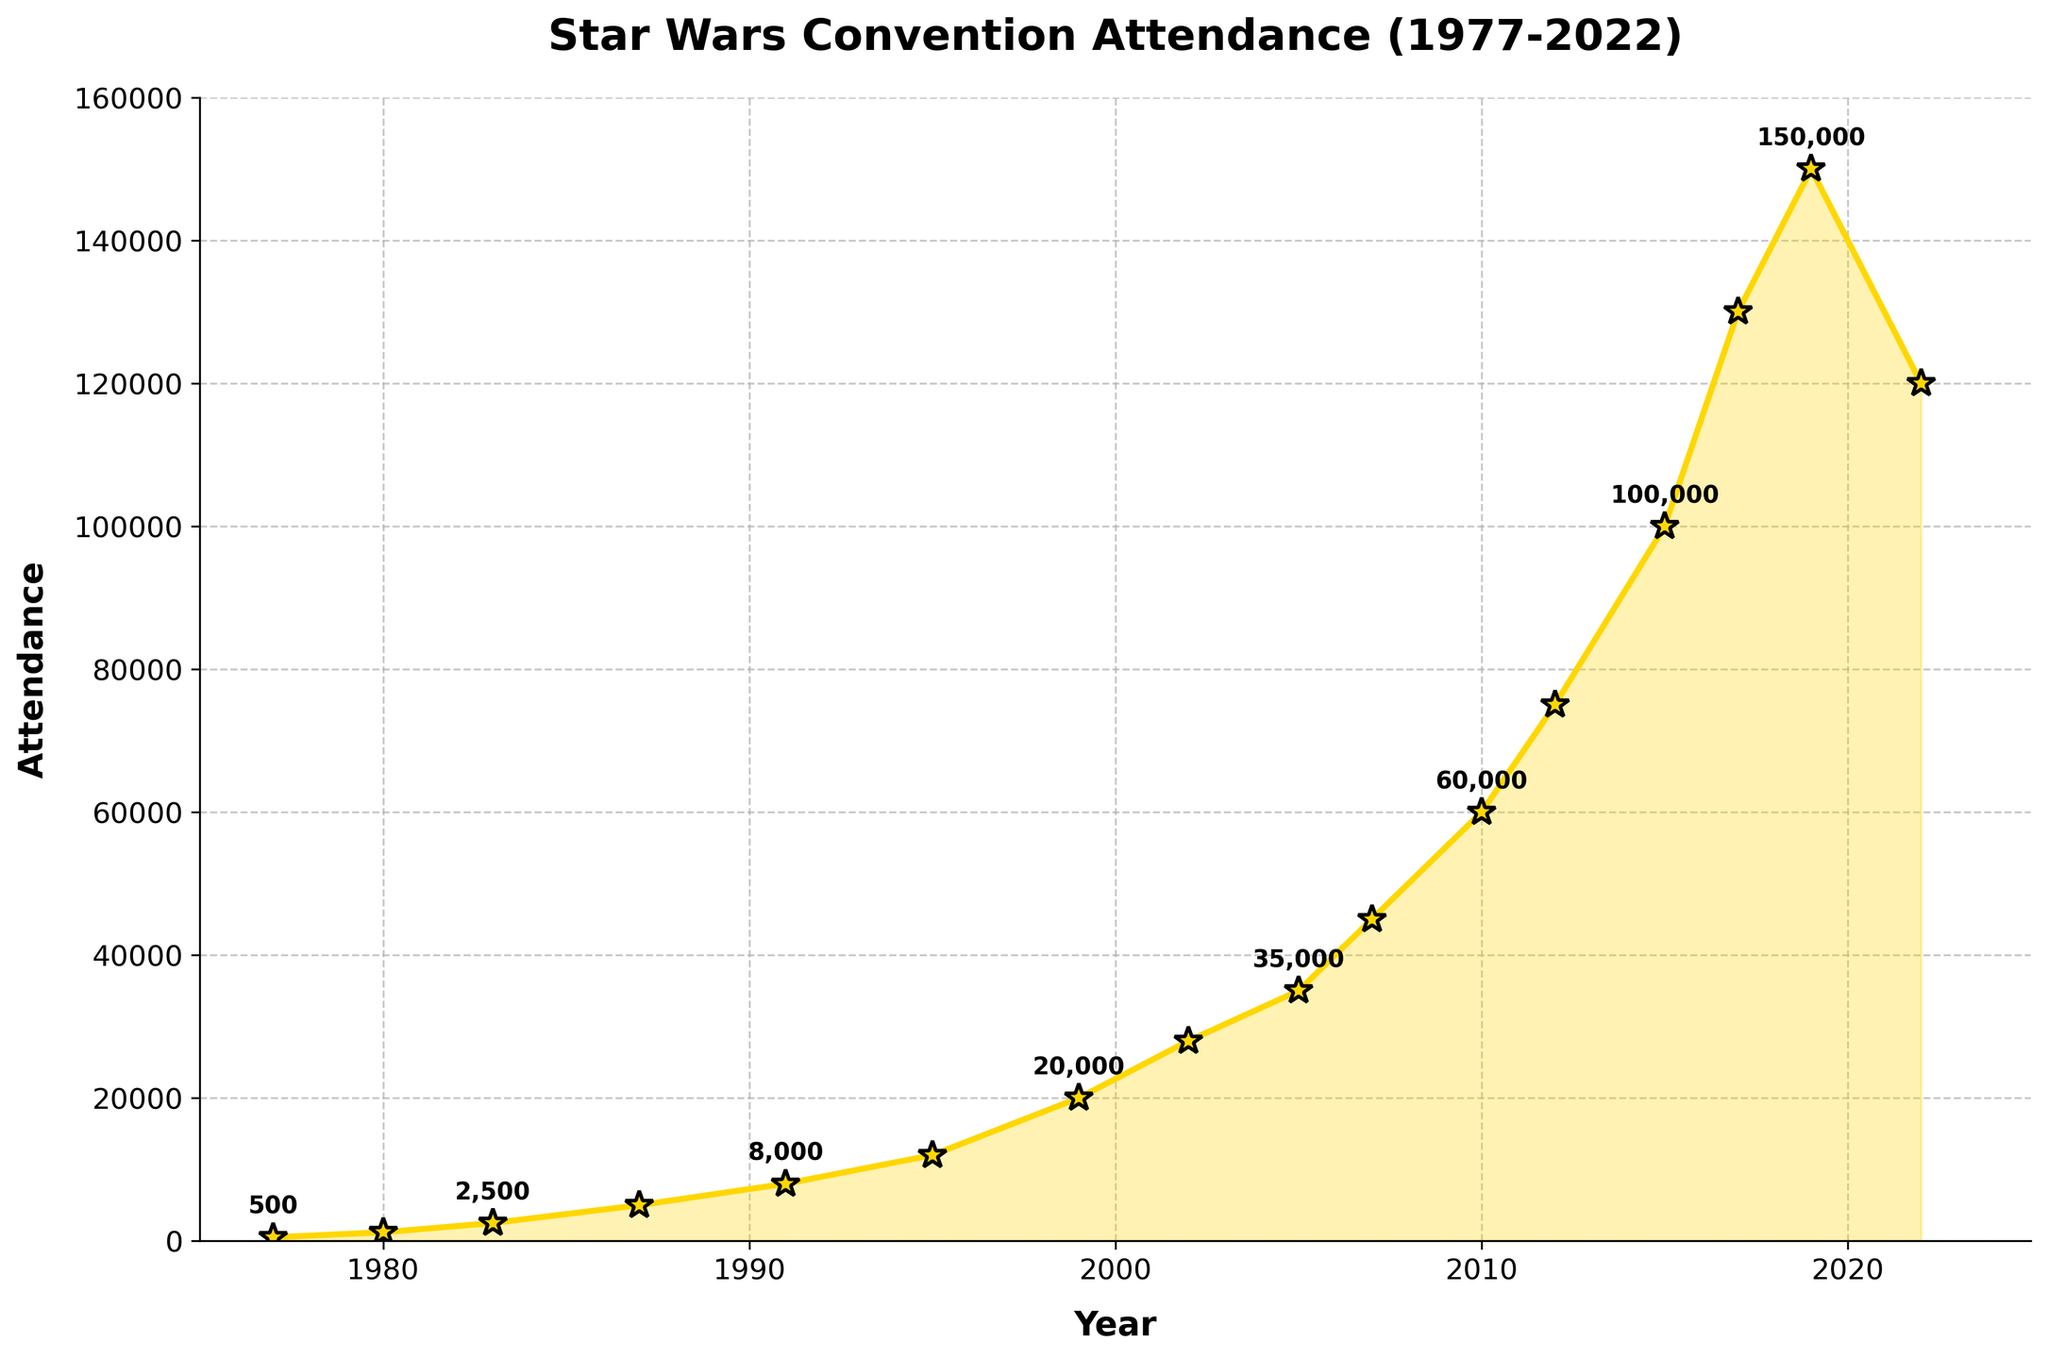Which year had the highest attendance at Star Wars conventions? The highest point on the graph is in 2019. The label close to this point indicates the attendance was 150,000.
Answer: 2019 What was the increase in attendance from 1977 to 1980? Attendance in 1977 was 500 and in 1980 was 1200. The increase is calculated as 1200 - 500.
Answer: 700 Which year had a larger attendance: 2005 or 2010? By comparing the points for 2005 and 2010, attendance in 2005 was 35,000 and in 2010 was 60,000.
Answer: 2010 During which period did the attendance grow the fastest? By observing the slope of the plotted line, the steepest increase occurred between 2015 and 2017.
Answer: 2015 to 2017 What is the average attendance from 2007 to 2015? Attendance values from 2007 to 2015 are 45000, 60000, 75000, and 100000. Sum these values (45000 + 60000 + 75000 + 100000 = 280000) and divide by the number of years (280000 / 4).
Answer: 70,000 How did the attendance change from 2019 to 2022? Attendance in 2019 was 150,000 and in 2022 was 120,000. The decrease is 150,000 - 120,000.
Answer: Decreased by 30,000 What was the percentage increase in attendance from 1995 to 2007? Attendance in 1995 was 12,000 and in 2007 was 45,000. Calculate the increase (45,000 - 12,000 = 33,000) and percentage increase (33,000 / 12,000 * 100).
Answer: 275% Is there any year where the attendance remained the same as the previous year? By examining the plot, there is no year where the attendance remained the same as the previous year.
Answer: No How many years did it take for the attendance to double from its value in 1999? Attendance in 1999 was 20,000. Doubling this value gives 40,000. By checking the plot, attendance reaches at least 40,000 in the year 2007.
Answer: 8 years What visual element indicates the fluctuations in attendance over the years? The fill between the line and the x-axis, which has a yellow shade of varying heights, indicates fluctuations. Greater height means greater attendance.
Answer: Filled area 